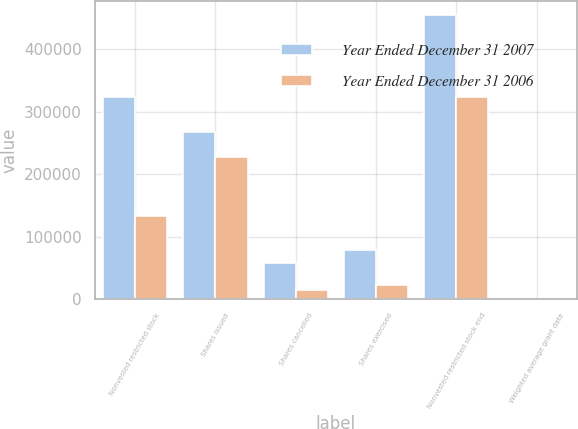<chart> <loc_0><loc_0><loc_500><loc_500><stacked_bar_chart><ecel><fcel>Nonvested restricted stock<fcel>Shares issued<fcel>Shares cancelled<fcel>Shares exercised<fcel>Nonvested restricted stock end<fcel>Weighted average grant date<nl><fcel>Year Ended December 31 2007<fcel>324289<fcel>267055<fcel>58086<fcel>78774<fcel>454484<fcel>34.77<nl><fcel>Year Ended December 31 2006<fcel>133500<fcel>227559<fcel>14770<fcel>22000<fcel>324289<fcel>32.95<nl></chart> 